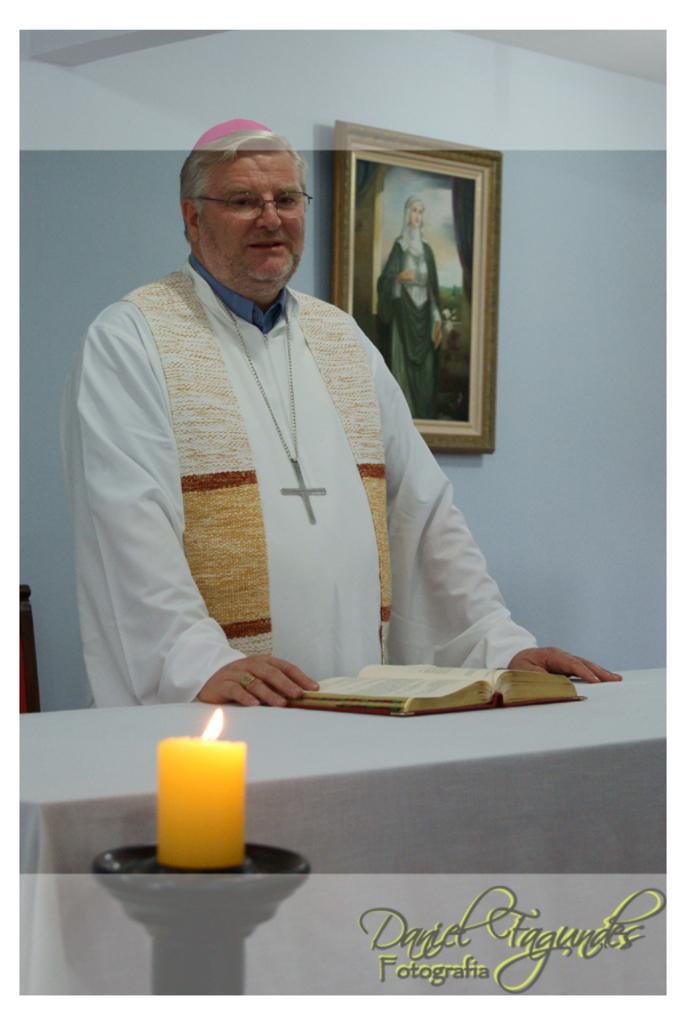Describe this image in one or two sentences. In this picture there is a man who is wearing white dress, cap and locket. He is standing near to the table. On the table I can see the book. In the bottom left corner there is a candle which is kept on this wood. In the bottom right corner there is a watermark. In the back I can see see the frame which is placed on the wall. In the frame I can see the person who is standing on the ground. 